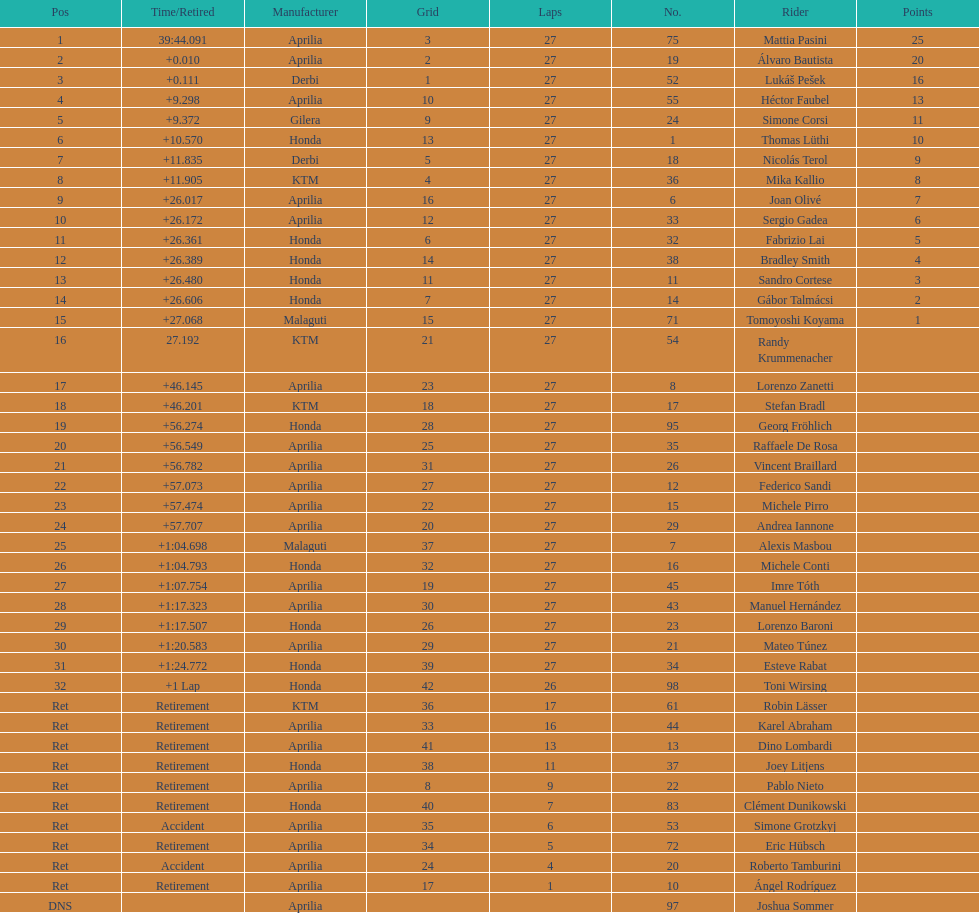How many racers did not use an aprilia or a honda? 9. 